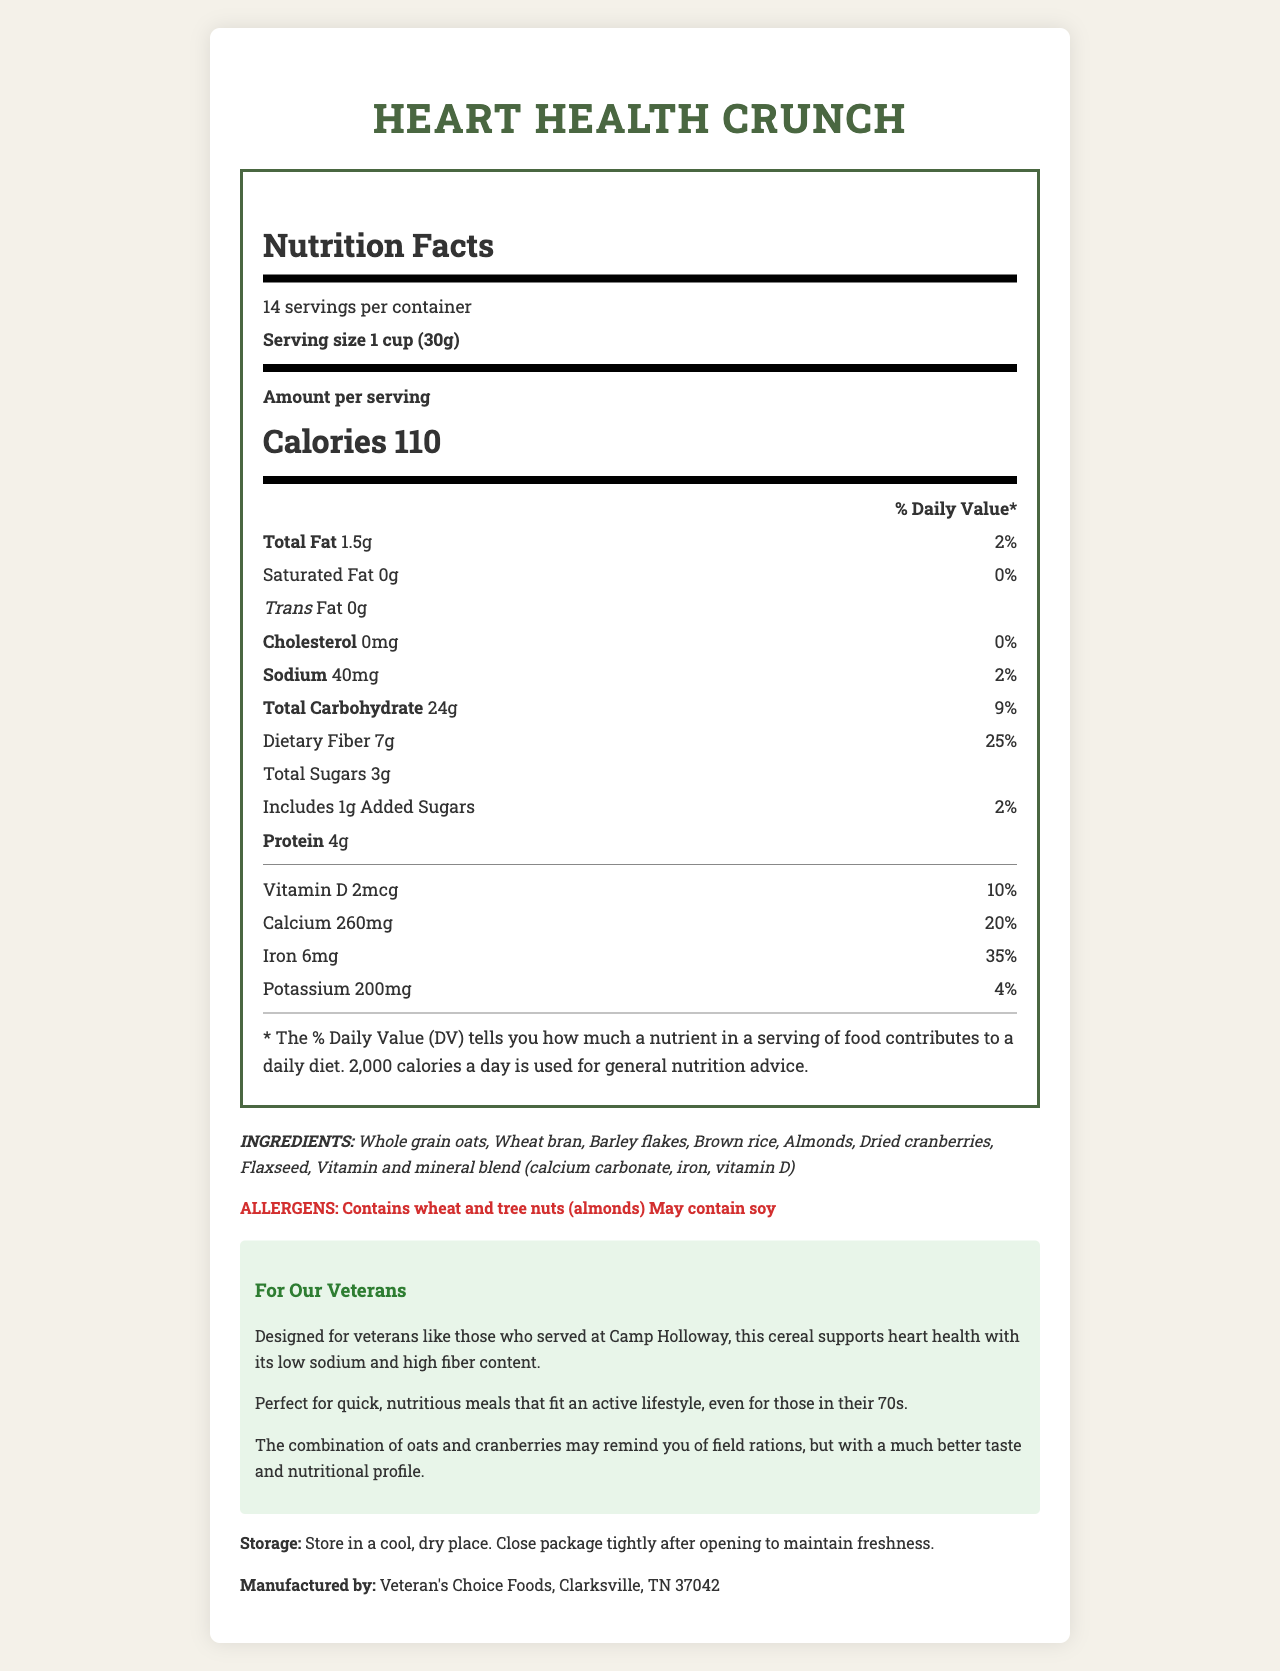what is the product name? The product name is clearly stated at the beginning of the document.
Answer: Heart Health Crunch how many servings are in the container? It is mentioned under the Nutrition Facts section as "14 servings per container."
Answer: 14 what is the serving size of the cereal? The serving size is listed under the Nutrition Facts section as "Serving size 1 cup (30g)."
Answer: 1 cup (30g) how many calories are in one serving? The number of calories per serving is prominently displayed under the Nutrition Facts as "Calories 110."
Answer: 110 what percentage of the daily value of iron does one serving provide? It is stated under the Nutrition Facts in the Vitamins and Minerals section as "Iron 6mg 35%."
Answer: 35% how much dietary fiber is in one serving? The amount of dietary fiber is listed under the Total Carbohydrate section as "Dietary Fiber 7g."
Answer: 7g is there any trans fat in the cereal? The Nutrition Facts label shows "Trans Fat 0g," indicating there is no trans fat.
Answer: No what is the primary benefit of this cereal for veterans? The veteran-specific information section explains the heart health benefits due to low sodium and high fiber content designed for veterans.
Answer: Supports heart health with low sodium and high fiber content which of the following ingredients is not listed? A. Whole grain oats B. Almonds C. Sugar D. Barley flakes The list of ingredients includes "Whole grain oats, Wheat bran, Barley flakes, Brown rice, Almonds, Dried cranberries, Flaxseed, Vitamin and mineral blend," but does not list "Sugar."
Answer: C. Sugar what is the percentage of the daily value of calcium provided by one serving? A. 10% B. 20% C. 30% D. 35% The Nutrition Facts shows "Calcium 260mg 20%," indicating one serving provides 20% of the daily value of calcium.
Answer: B. 20% is the cereal suitable for people with soy allergies? The allergens section states, "May contain soy," which indicates there is a potential risk for people with soy allergies.
Answer: It may not be safe describe the main idea of the document. The document contains a Nutrition Facts Label for Heart Health Crunch cereal, outlining its health benefits, especially for veterans. It lists detailed nutritional content, ingredients, allergens, storage instructions, and manufacturing information, emphasizing its role in supporting heart health with low sodium and high fiber.
Answer: The main idea of the document is to provide the nutritional information of Heart Health Crunch cereal, which is low in sodium and high in fiber, making it suitable for heart health. It includes details about serving size, calories, vitamins and minerals, ingredients, allergens, and specific information for veterans. what is the address of the manufacturer? The document states the manufacturer is "Veteran's Choice Foods, Clarksville, TN 37042," but it does not provide the exact address.
Answer: Not enough information 